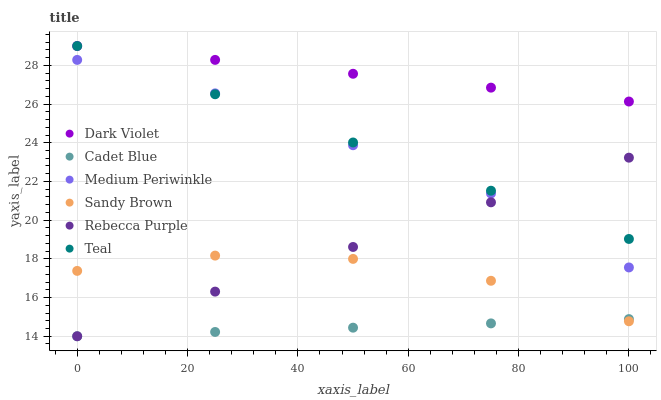Does Cadet Blue have the minimum area under the curve?
Answer yes or no. Yes. Does Dark Violet have the maximum area under the curve?
Answer yes or no. Yes. Does Medium Periwinkle have the minimum area under the curve?
Answer yes or no. No. Does Medium Periwinkle have the maximum area under the curve?
Answer yes or no. No. Is Cadet Blue the smoothest?
Answer yes or no. Yes. Is Sandy Brown the roughest?
Answer yes or no. Yes. Is Medium Periwinkle the smoothest?
Answer yes or no. No. Is Medium Periwinkle the roughest?
Answer yes or no. No. Does Cadet Blue have the lowest value?
Answer yes or no. Yes. Does Medium Periwinkle have the lowest value?
Answer yes or no. No. Does Teal have the highest value?
Answer yes or no. Yes. Does Medium Periwinkle have the highest value?
Answer yes or no. No. Is Sandy Brown less than Medium Periwinkle?
Answer yes or no. Yes. Is Dark Violet greater than Sandy Brown?
Answer yes or no. Yes. Does Cadet Blue intersect Sandy Brown?
Answer yes or no. Yes. Is Cadet Blue less than Sandy Brown?
Answer yes or no. No. Is Cadet Blue greater than Sandy Brown?
Answer yes or no. No. Does Sandy Brown intersect Medium Periwinkle?
Answer yes or no. No. 